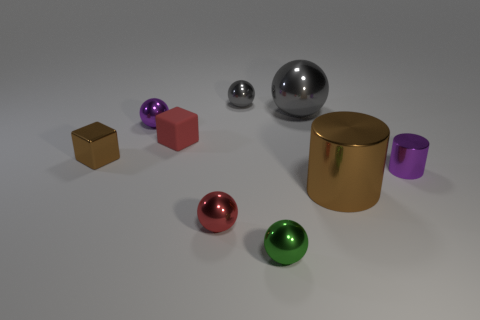Can you describe the textures of the objects present? Certainly! In the image, there are objects with both matte and shiny textures. The spheres have a polished surface, reflecting light and their surroundings, while the cubes appear to have a more matte finish, diffusing light softly. 